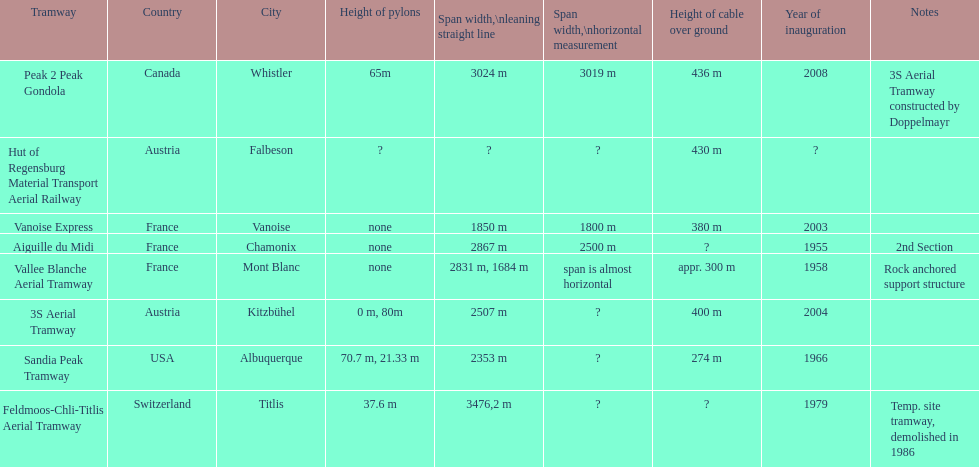How many aerial tramways are located in france? 3. 